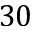Convert formula to latex. <formula><loc_0><loc_0><loc_500><loc_500>3 0</formula> 